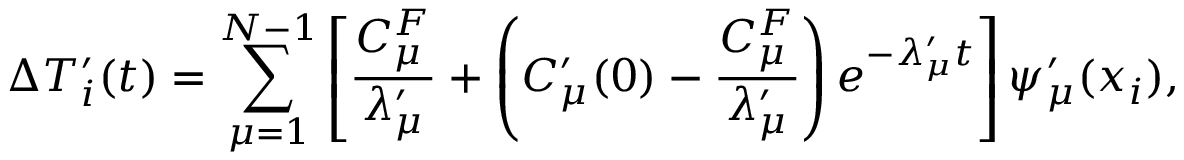<formula> <loc_0><loc_0><loc_500><loc_500>\Delta T _ { i } ^ { \prime } ( t ) = \sum _ { \mu = 1 } ^ { N - 1 } \left [ \frac { C _ { \mu } ^ { F } } { \lambda _ { \mu } ^ { \prime } } + \left ( C _ { \mu } ^ { \prime } ( 0 ) - \frac { C _ { \mu } ^ { F } } { \lambda _ { \mu } ^ { \prime } } \right ) e ^ { - \lambda _ { \mu } ^ { \prime } t } \right ] \psi _ { \mu } ^ { \prime } ( x _ { i } ) ,</formula> 